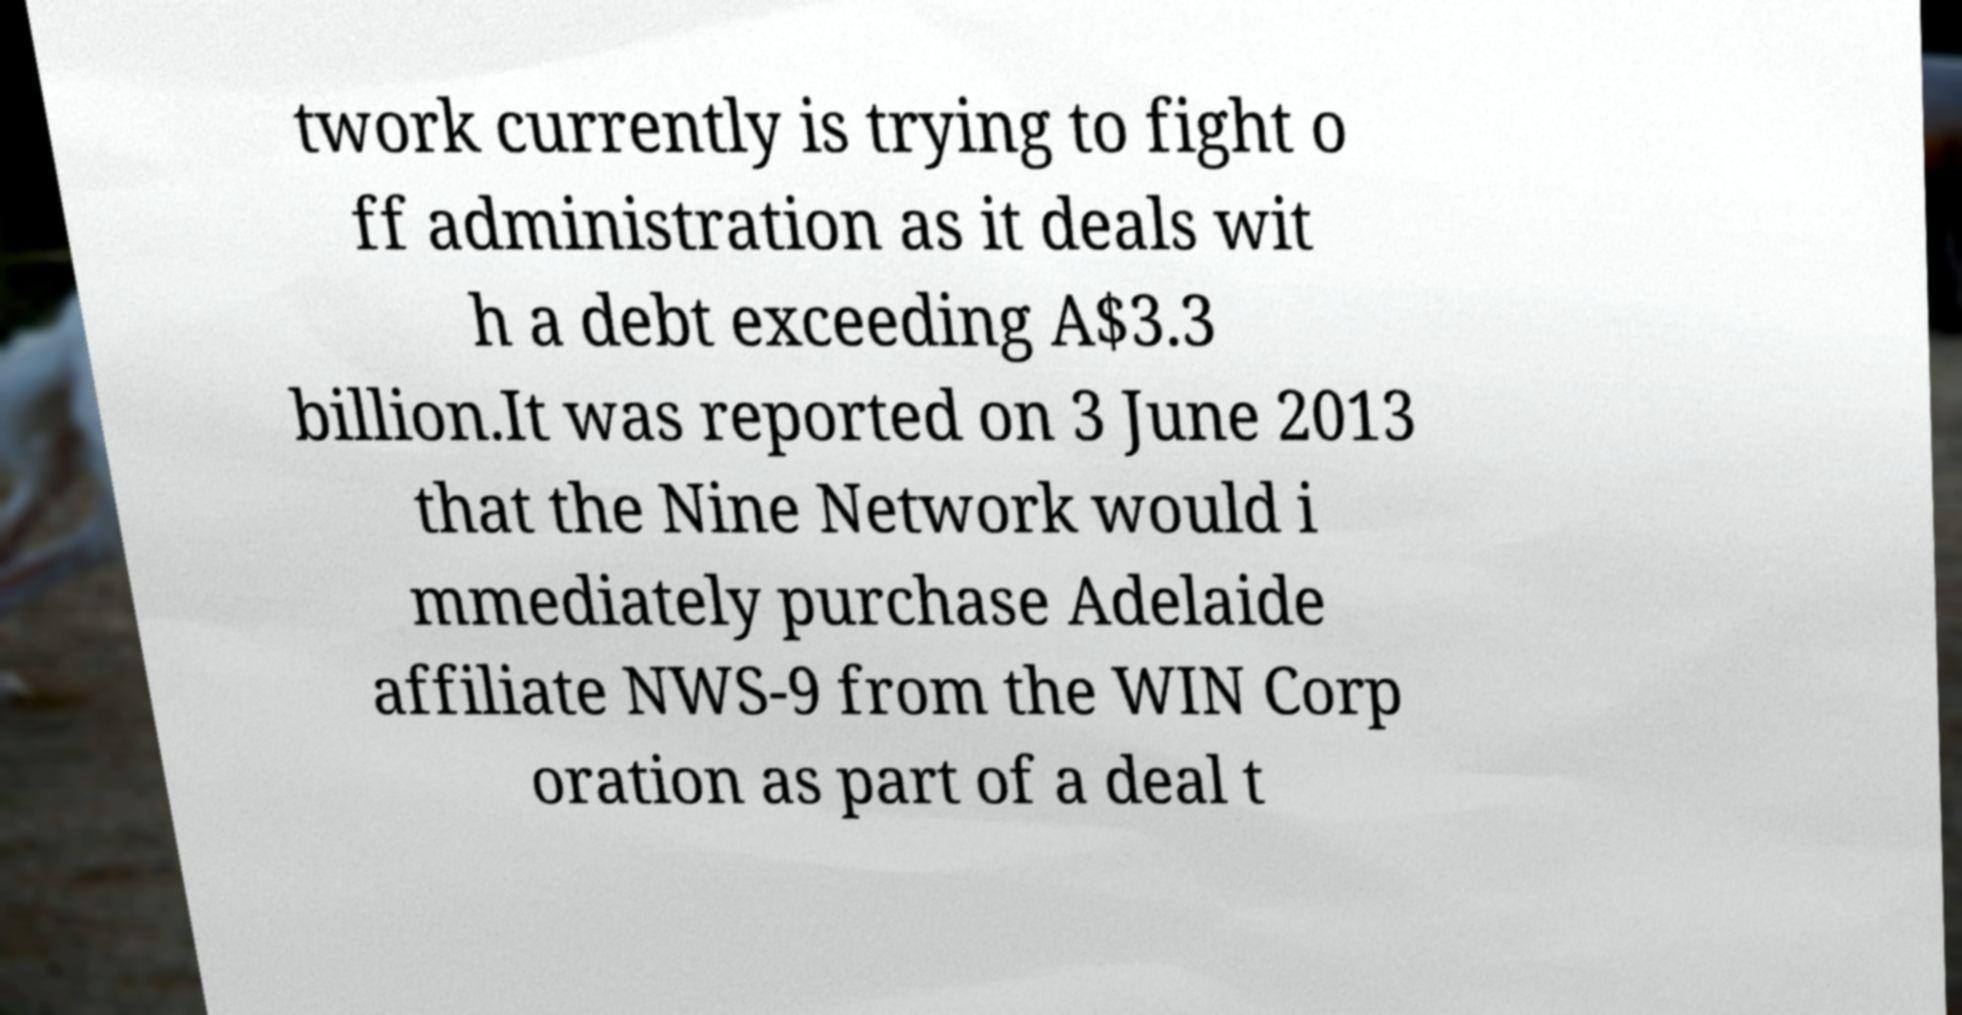Can you read and provide the text displayed in the image?This photo seems to have some interesting text. Can you extract and type it out for me? twork currently is trying to fight o ff administration as it deals wit h a debt exceeding A$3.3 billion.It was reported on 3 June 2013 that the Nine Network would i mmediately purchase Adelaide affiliate NWS-9 from the WIN Corp oration as part of a deal t 